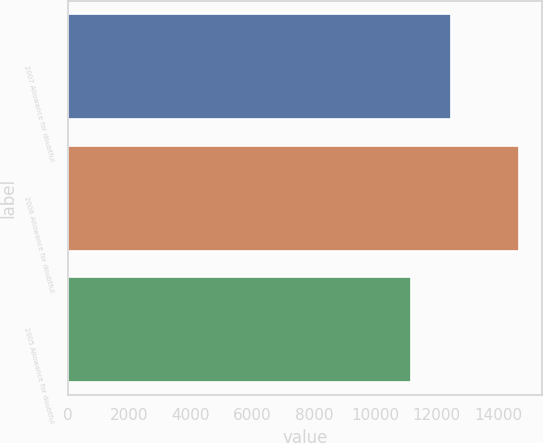<chart> <loc_0><loc_0><loc_500><loc_500><bar_chart><fcel>2007 Allowance for doubtful<fcel>2006 Allowance for doubtful<fcel>2005 Allowance for doubtful<nl><fcel>12468<fcel>14677<fcel>11162<nl></chart> 